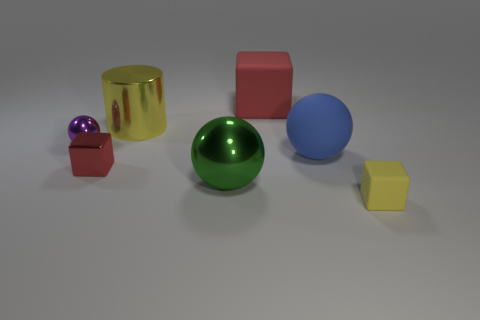How many objects are large cyan cylinders or large things that are behind the large yellow cylinder?
Provide a succinct answer. 1. Is the material of the large red object that is behind the purple ball the same as the blue object?
Offer a very short reply. Yes. Are there any other things that have the same size as the red shiny block?
Keep it short and to the point. Yes. What material is the yellow thing that is behind the rubber cube that is in front of the big blue rubber thing?
Make the answer very short. Metal. Is the number of small red metal things right of the large yellow metallic object greater than the number of red matte objects that are to the left of the purple metallic object?
Your answer should be compact. No. The purple metallic thing has what size?
Your answer should be very brief. Small. Does the large rubber object that is to the left of the big blue ball have the same color as the small metal sphere?
Make the answer very short. No. Is there any other thing that has the same shape as the small yellow rubber object?
Make the answer very short. Yes. There is a matte block that is behind the tiny yellow object; is there a red object to the right of it?
Keep it short and to the point. No. Are there fewer tiny purple objects behind the yellow cylinder than large blue objects in front of the tiny rubber block?
Provide a short and direct response. No. 